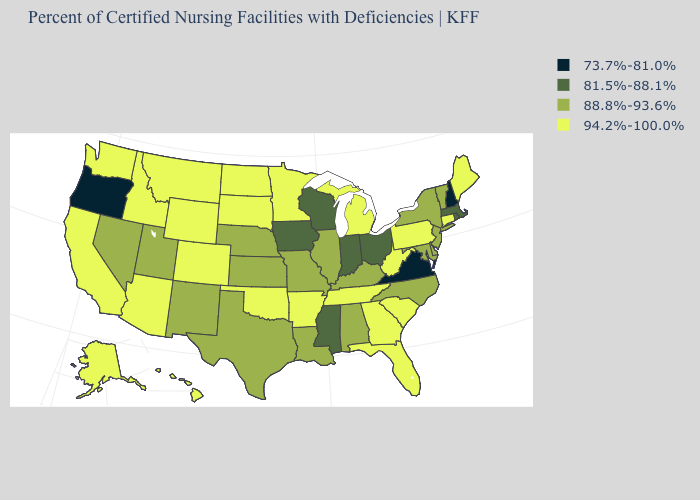What is the value of South Carolina?
Be succinct. 94.2%-100.0%. Name the states that have a value in the range 73.7%-81.0%?
Answer briefly. New Hampshire, Oregon, Virginia. Is the legend a continuous bar?
Give a very brief answer. No. Among the states that border North Dakota , which have the lowest value?
Quick response, please. Minnesota, Montana, South Dakota. Which states have the lowest value in the USA?
Quick response, please. New Hampshire, Oregon, Virginia. What is the highest value in states that border Pennsylvania?
Answer briefly. 94.2%-100.0%. Does Connecticut have a higher value than Vermont?
Concise answer only. Yes. What is the lowest value in the Northeast?
Answer briefly. 73.7%-81.0%. Does Connecticut have a higher value than Colorado?
Keep it brief. No. Name the states that have a value in the range 73.7%-81.0%?
Answer briefly. New Hampshire, Oregon, Virginia. Name the states that have a value in the range 81.5%-88.1%?
Write a very short answer. Indiana, Iowa, Massachusetts, Mississippi, Ohio, Rhode Island, Wisconsin. Does Arkansas have the highest value in the South?
Keep it brief. Yes. Name the states that have a value in the range 81.5%-88.1%?
Quick response, please. Indiana, Iowa, Massachusetts, Mississippi, Ohio, Rhode Island, Wisconsin. What is the value of Connecticut?
Be succinct. 94.2%-100.0%. What is the lowest value in the USA?
Give a very brief answer. 73.7%-81.0%. 